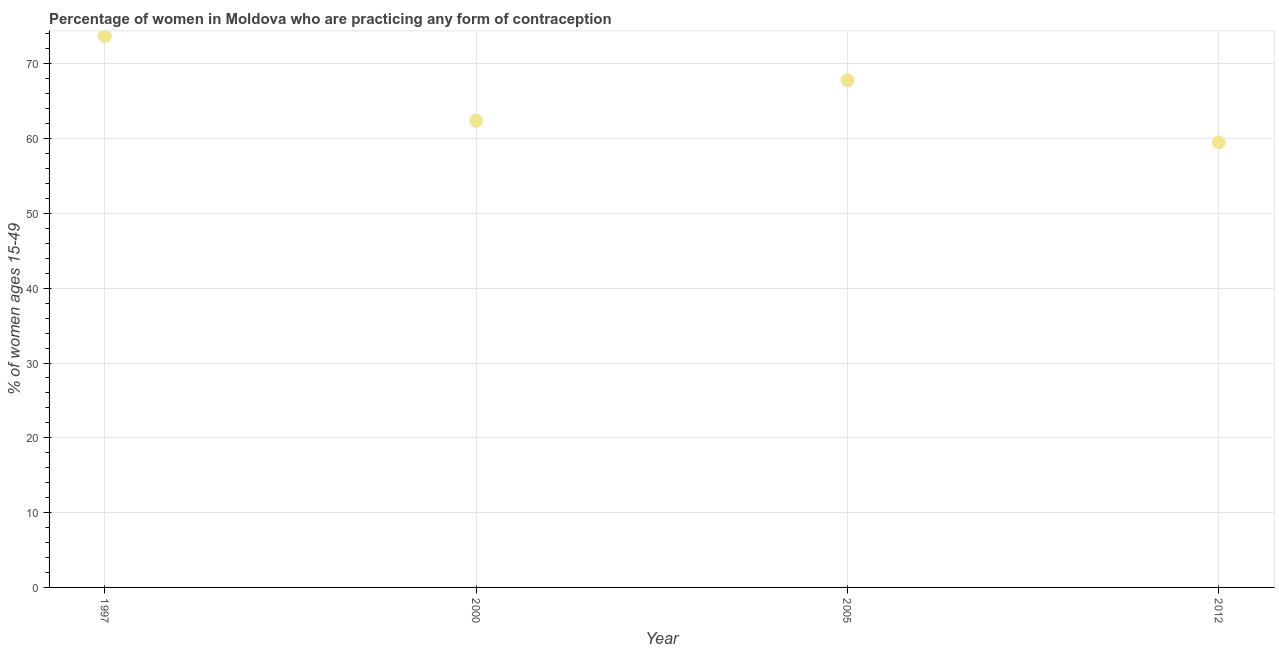What is the contraceptive prevalence in 2012?
Your answer should be compact. 59.5. Across all years, what is the maximum contraceptive prevalence?
Keep it short and to the point. 73.7. Across all years, what is the minimum contraceptive prevalence?
Your answer should be compact. 59.5. What is the sum of the contraceptive prevalence?
Make the answer very short. 263.4. What is the difference between the contraceptive prevalence in 1997 and 2012?
Offer a very short reply. 14.2. What is the average contraceptive prevalence per year?
Provide a short and direct response. 65.85. What is the median contraceptive prevalence?
Give a very brief answer. 65.1. In how many years, is the contraceptive prevalence greater than 46 %?
Give a very brief answer. 4. What is the ratio of the contraceptive prevalence in 2000 to that in 2012?
Keep it short and to the point. 1.05. Is the contraceptive prevalence in 2000 less than that in 2012?
Provide a short and direct response. No. What is the difference between the highest and the second highest contraceptive prevalence?
Give a very brief answer. 5.9. What is the difference between the highest and the lowest contraceptive prevalence?
Ensure brevity in your answer.  14.2. In how many years, is the contraceptive prevalence greater than the average contraceptive prevalence taken over all years?
Provide a succinct answer. 2. Does the contraceptive prevalence monotonically increase over the years?
Ensure brevity in your answer.  No. How many years are there in the graph?
Ensure brevity in your answer.  4. Are the values on the major ticks of Y-axis written in scientific E-notation?
Ensure brevity in your answer.  No. Does the graph contain grids?
Make the answer very short. Yes. What is the title of the graph?
Offer a terse response. Percentage of women in Moldova who are practicing any form of contraception. What is the label or title of the Y-axis?
Offer a terse response. % of women ages 15-49. What is the % of women ages 15-49 in 1997?
Your response must be concise. 73.7. What is the % of women ages 15-49 in 2000?
Ensure brevity in your answer.  62.4. What is the % of women ages 15-49 in 2005?
Offer a very short reply. 67.8. What is the % of women ages 15-49 in 2012?
Your response must be concise. 59.5. What is the difference between the % of women ages 15-49 in 1997 and 2000?
Keep it short and to the point. 11.3. What is the difference between the % of women ages 15-49 in 1997 and 2005?
Give a very brief answer. 5.9. What is the ratio of the % of women ages 15-49 in 1997 to that in 2000?
Your answer should be compact. 1.18. What is the ratio of the % of women ages 15-49 in 1997 to that in 2005?
Your answer should be very brief. 1.09. What is the ratio of the % of women ages 15-49 in 1997 to that in 2012?
Give a very brief answer. 1.24. What is the ratio of the % of women ages 15-49 in 2000 to that in 2005?
Provide a short and direct response. 0.92. What is the ratio of the % of women ages 15-49 in 2000 to that in 2012?
Provide a short and direct response. 1.05. What is the ratio of the % of women ages 15-49 in 2005 to that in 2012?
Make the answer very short. 1.14. 